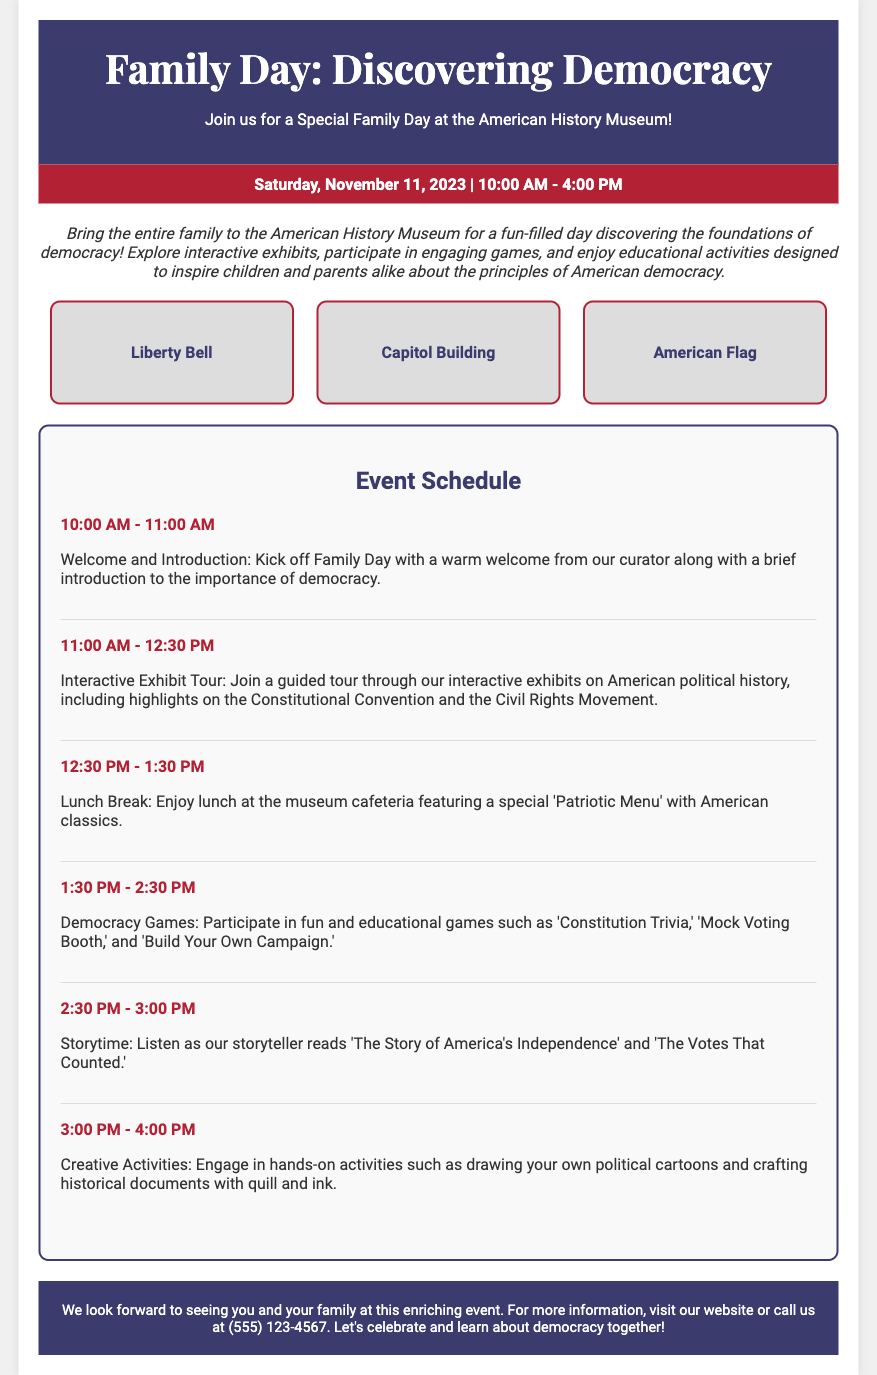What is the event date? The event date is specified in the document as "Saturday, November 11, 2023."
Answer: Saturday, November 11, 2023 What time does the event start? The start time is given in the document, indicating the event begins at "10:00 AM."
Answer: 10:00 AM What is the first activity listed in the schedule? The first activity is described in the schedule as "Welcome and Introduction."
Answer: Welcome and Introduction How long is the lunch break? The duration of the lunch break is indicated under the schedule section as "1 hour."
Answer: 1 hour What type of food will be available during lunch? The lunch menu description states it features a "Patriotic Menu."
Answer: Patriotic Menu What is one of the games mentioned in the event? The document includes a game titled "Constitution Trivia" as part of the Democracy Games.
Answer: Constitution Trivia How many graphics are displayed on the flyer? The document describes a total of three graphics in the graphic container section.
Answer: Three What will the storyteller read during Storytime? The document specifies that the storyteller will read "The Story of America's Independence" and "The Votes That Counted."
Answer: The Story of America's Independence and The Votes That Counted What is the target audience for this event? The flyer states that the event is designed for families, suggesting it targets children and their parents.
Answer: Families 